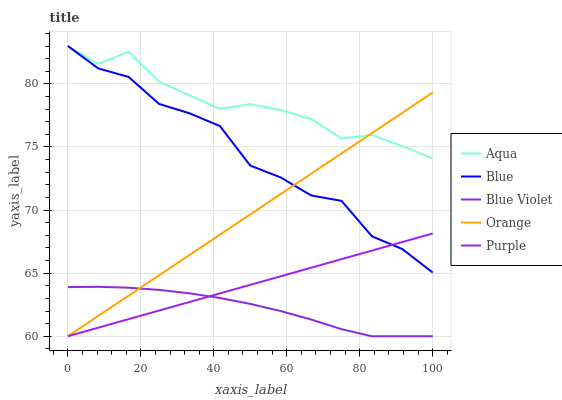Does Blue Violet have the minimum area under the curve?
Answer yes or no. Yes. Does Aqua have the maximum area under the curve?
Answer yes or no. Yes. Does Orange have the minimum area under the curve?
Answer yes or no. No. Does Orange have the maximum area under the curve?
Answer yes or no. No. Is Purple the smoothest?
Answer yes or no. Yes. Is Blue the roughest?
Answer yes or no. Yes. Is Orange the smoothest?
Answer yes or no. No. Is Orange the roughest?
Answer yes or no. No. Does Aqua have the lowest value?
Answer yes or no. No. Does Orange have the highest value?
Answer yes or no. No. Is Blue Violet less than Aqua?
Answer yes or no. Yes. Is Aqua greater than Blue Violet?
Answer yes or no. Yes. Does Blue Violet intersect Aqua?
Answer yes or no. No. 